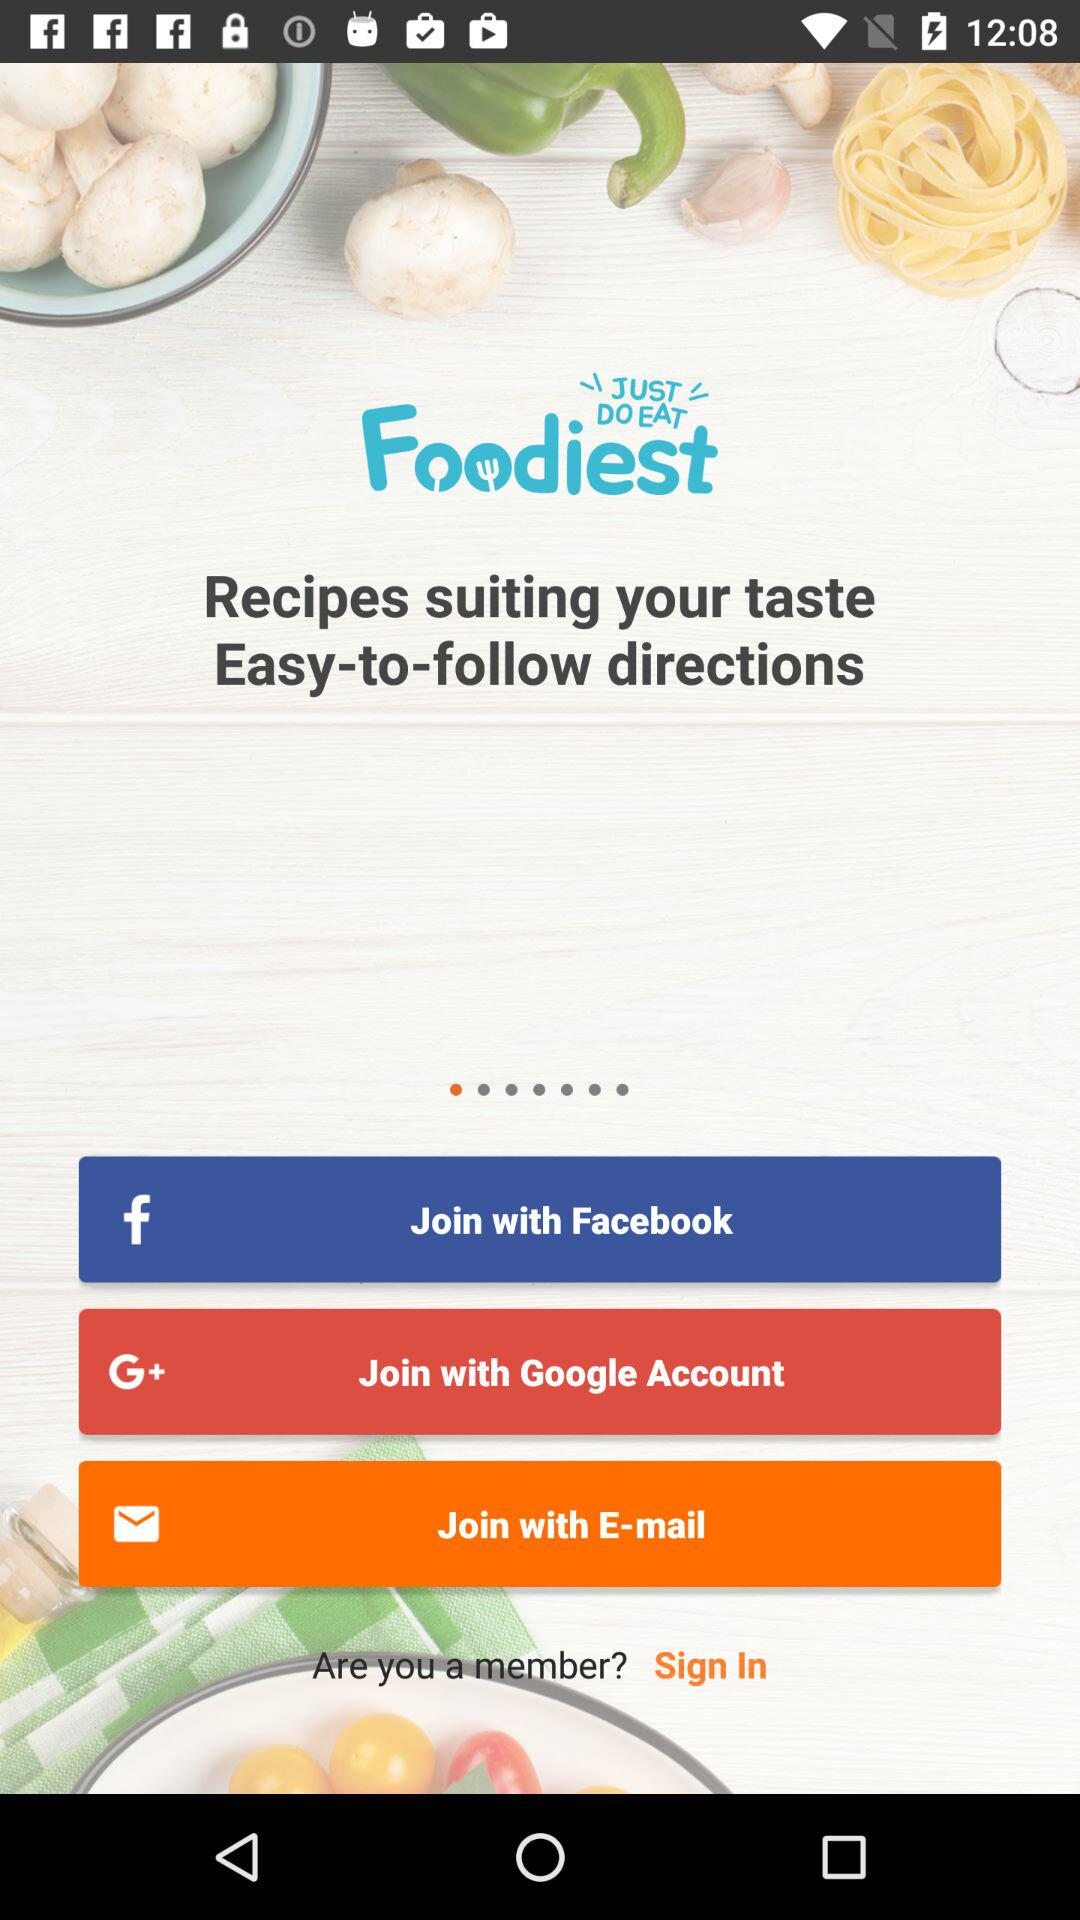Which account can I use to log in? You can use "Facebook", "Google" and "E-mail" accounts to log in. 